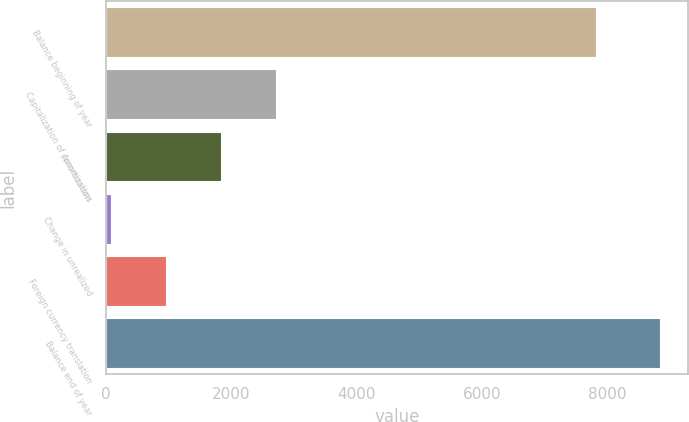Convert chart to OTSL. <chart><loc_0><loc_0><loc_500><loc_500><bar_chart><fcel>Balance beginning of year<fcel>Capitalization of commissions<fcel>Amortization<fcel>Change in unrealized<fcel>Foreign currency translation<fcel>Balance end of year<nl><fcel>7826<fcel>2711.5<fcel>1835<fcel>82<fcel>958.5<fcel>8847<nl></chart> 